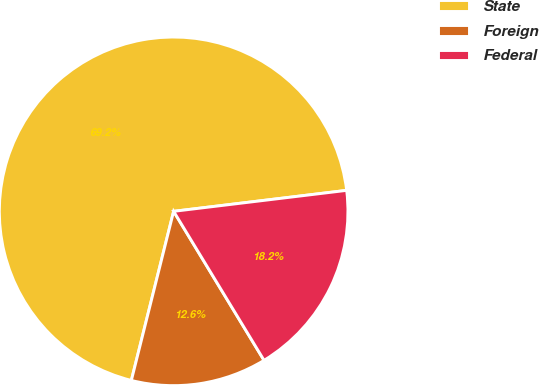<chart> <loc_0><loc_0><loc_500><loc_500><pie_chart><fcel>State<fcel>Foreign<fcel>Federal<nl><fcel>69.18%<fcel>12.58%<fcel>18.24%<nl></chart> 